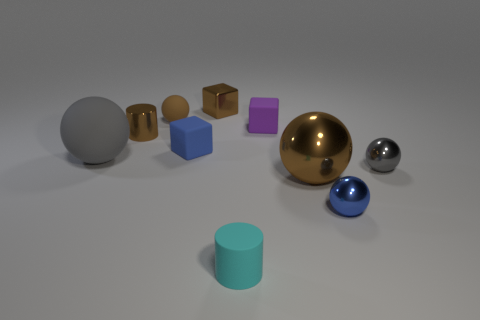Subtract all small rubber cubes. How many cubes are left? 1 Subtract all blue balls. How many balls are left? 4 Subtract 2 cylinders. How many cylinders are left? 0 Subtract all purple cylinders. Subtract all red cubes. How many cylinders are left? 2 Subtract all yellow spheres. How many cyan cylinders are left? 1 Subtract all tiny metal cylinders. Subtract all small objects. How many objects are left? 1 Add 4 small rubber cubes. How many small rubber cubes are left? 6 Add 4 large gray balls. How many large gray balls exist? 5 Subtract 0 purple cylinders. How many objects are left? 10 Subtract all blocks. How many objects are left? 7 